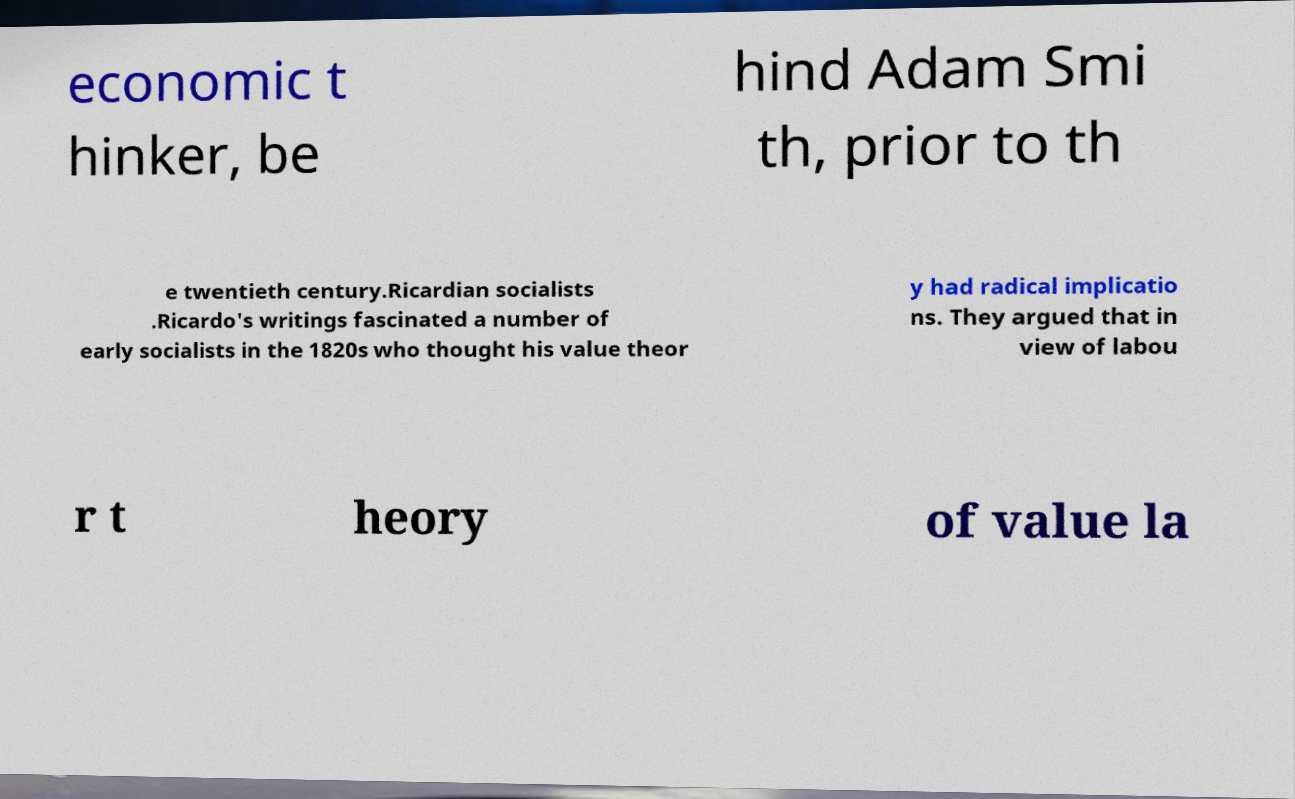Could you assist in decoding the text presented in this image and type it out clearly? economic t hinker, be hind Adam Smi th, prior to th e twentieth century.Ricardian socialists .Ricardo's writings fascinated a number of early socialists in the 1820s who thought his value theor y had radical implicatio ns. They argued that in view of labou r t heory of value la 